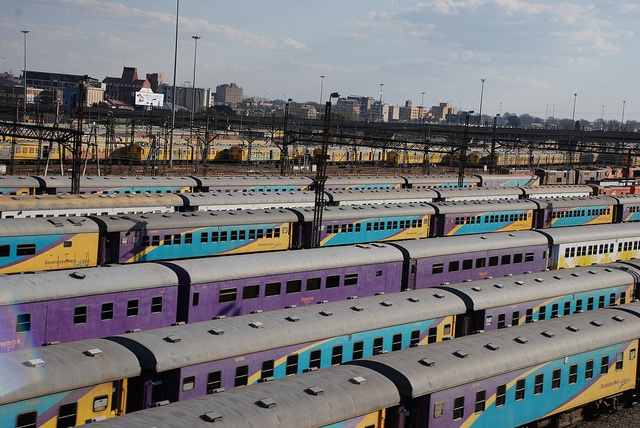Describe the objects in this image and their specific colors. I can see train in gray, darkgray, and black tones, train in gray, darkgray, purple, and black tones, train in gray, darkgray, and black tones, train in gray, black, darkgray, and teal tones, and train in gray, darkgray, tan, and black tones in this image. 